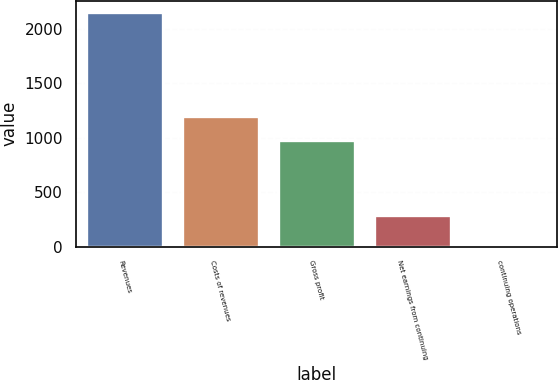<chart> <loc_0><loc_0><loc_500><loc_500><bar_chart><fcel>Revenues<fcel>Costs of revenues<fcel>Gross profit<fcel>Net earnings from continuing<fcel>continuing operations<nl><fcel>2150.1<fcel>1196.85<fcel>981.9<fcel>291.6<fcel>0.56<nl></chart> 